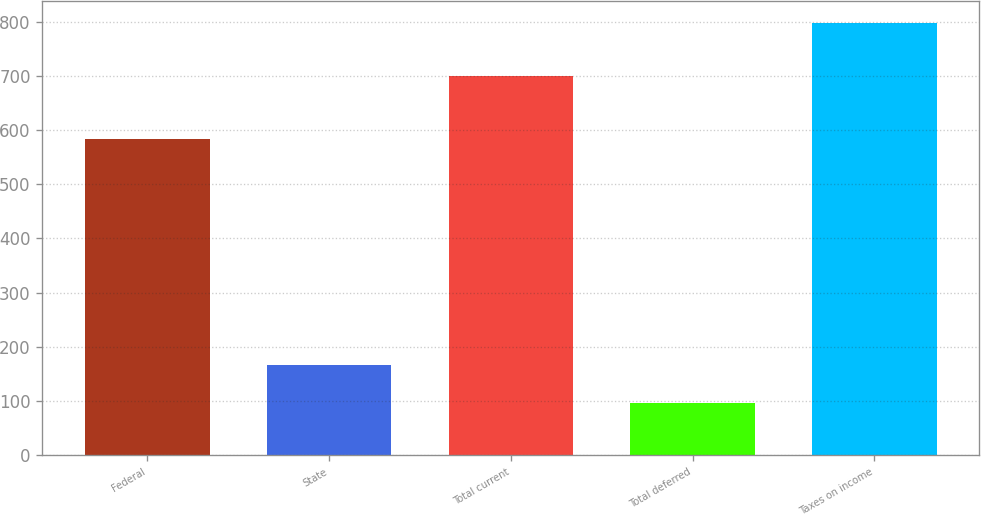<chart> <loc_0><loc_0><loc_500><loc_500><bar_chart><fcel>Federal<fcel>State<fcel>Total current<fcel>Total deferred<fcel>Taxes on income<nl><fcel>584<fcel>167.1<fcel>701<fcel>97<fcel>798<nl></chart> 